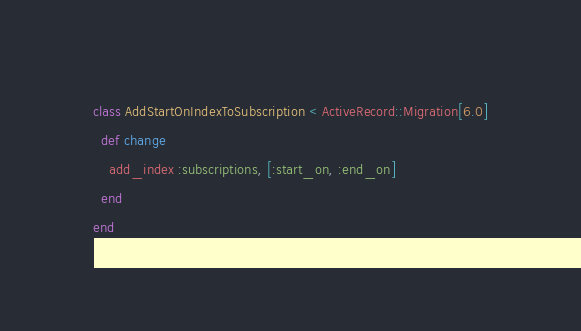<code> <loc_0><loc_0><loc_500><loc_500><_Ruby_>class AddStartOnIndexToSubscription < ActiveRecord::Migration[6.0]
  def change
    add_index :subscriptions, [:start_on, :end_on]
  end
end
</code> 